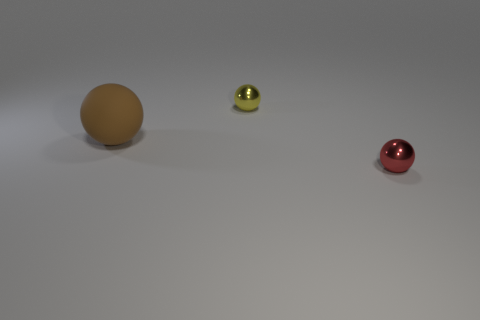There is a object that is right of the rubber object and left of the tiny red object; what is its material?
Your answer should be compact. Metal. Do the red thing in front of the brown sphere and the thing that is left of the yellow thing have the same shape?
Your answer should be very brief. Yes. Are there any other things that have the same material as the tiny yellow thing?
Make the answer very short. Yes. What number of other objects are there of the same shape as the big object?
Give a very brief answer. 2. There is a sphere that is the same size as the red metallic thing; what is its color?
Keep it short and to the point. Yellow. What number of cubes are tiny green things or small red shiny objects?
Give a very brief answer. 0. What number of tiny green rubber balls are there?
Your answer should be very brief. 0. There is a red metal object; does it have the same shape as the object that is on the left side of the tiny yellow ball?
Give a very brief answer. Yes. What number of things are either small yellow things or small red things?
Your answer should be compact. 2. Does the tiny thing behind the tiny red metal object have the same shape as the red thing?
Your answer should be compact. Yes. 